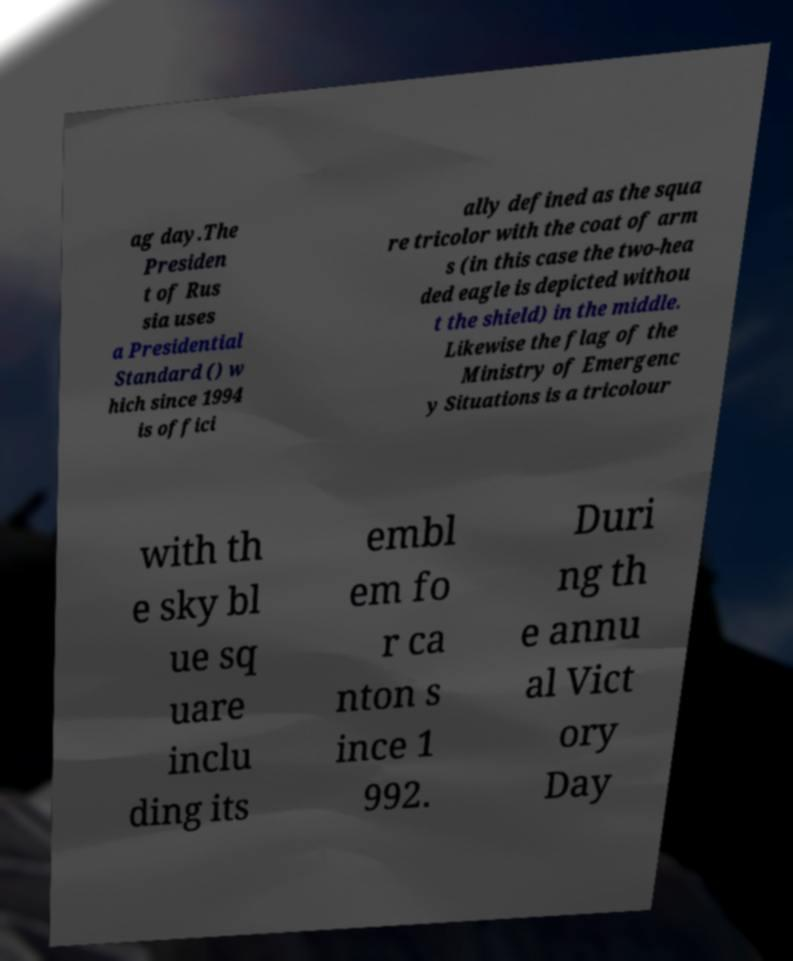Can you accurately transcribe the text from the provided image for me? ag day.The Presiden t of Rus sia uses a Presidential Standard () w hich since 1994 is offici ally defined as the squa re tricolor with the coat of arm s (in this case the two-hea ded eagle is depicted withou t the shield) in the middle. Likewise the flag of the Ministry of Emergenc y Situations is a tricolour with th e sky bl ue sq uare inclu ding its embl em fo r ca nton s ince 1 992. Duri ng th e annu al Vict ory Day 